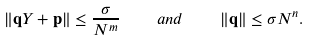<formula> <loc_0><loc_0><loc_500><loc_500>\| \mathbf q Y + \mathbf p \| \leq \frac { \sigma } { N ^ { m } } \quad a n d \quad \| \mathbf q \| \leq \sigma N ^ { n } .</formula> 